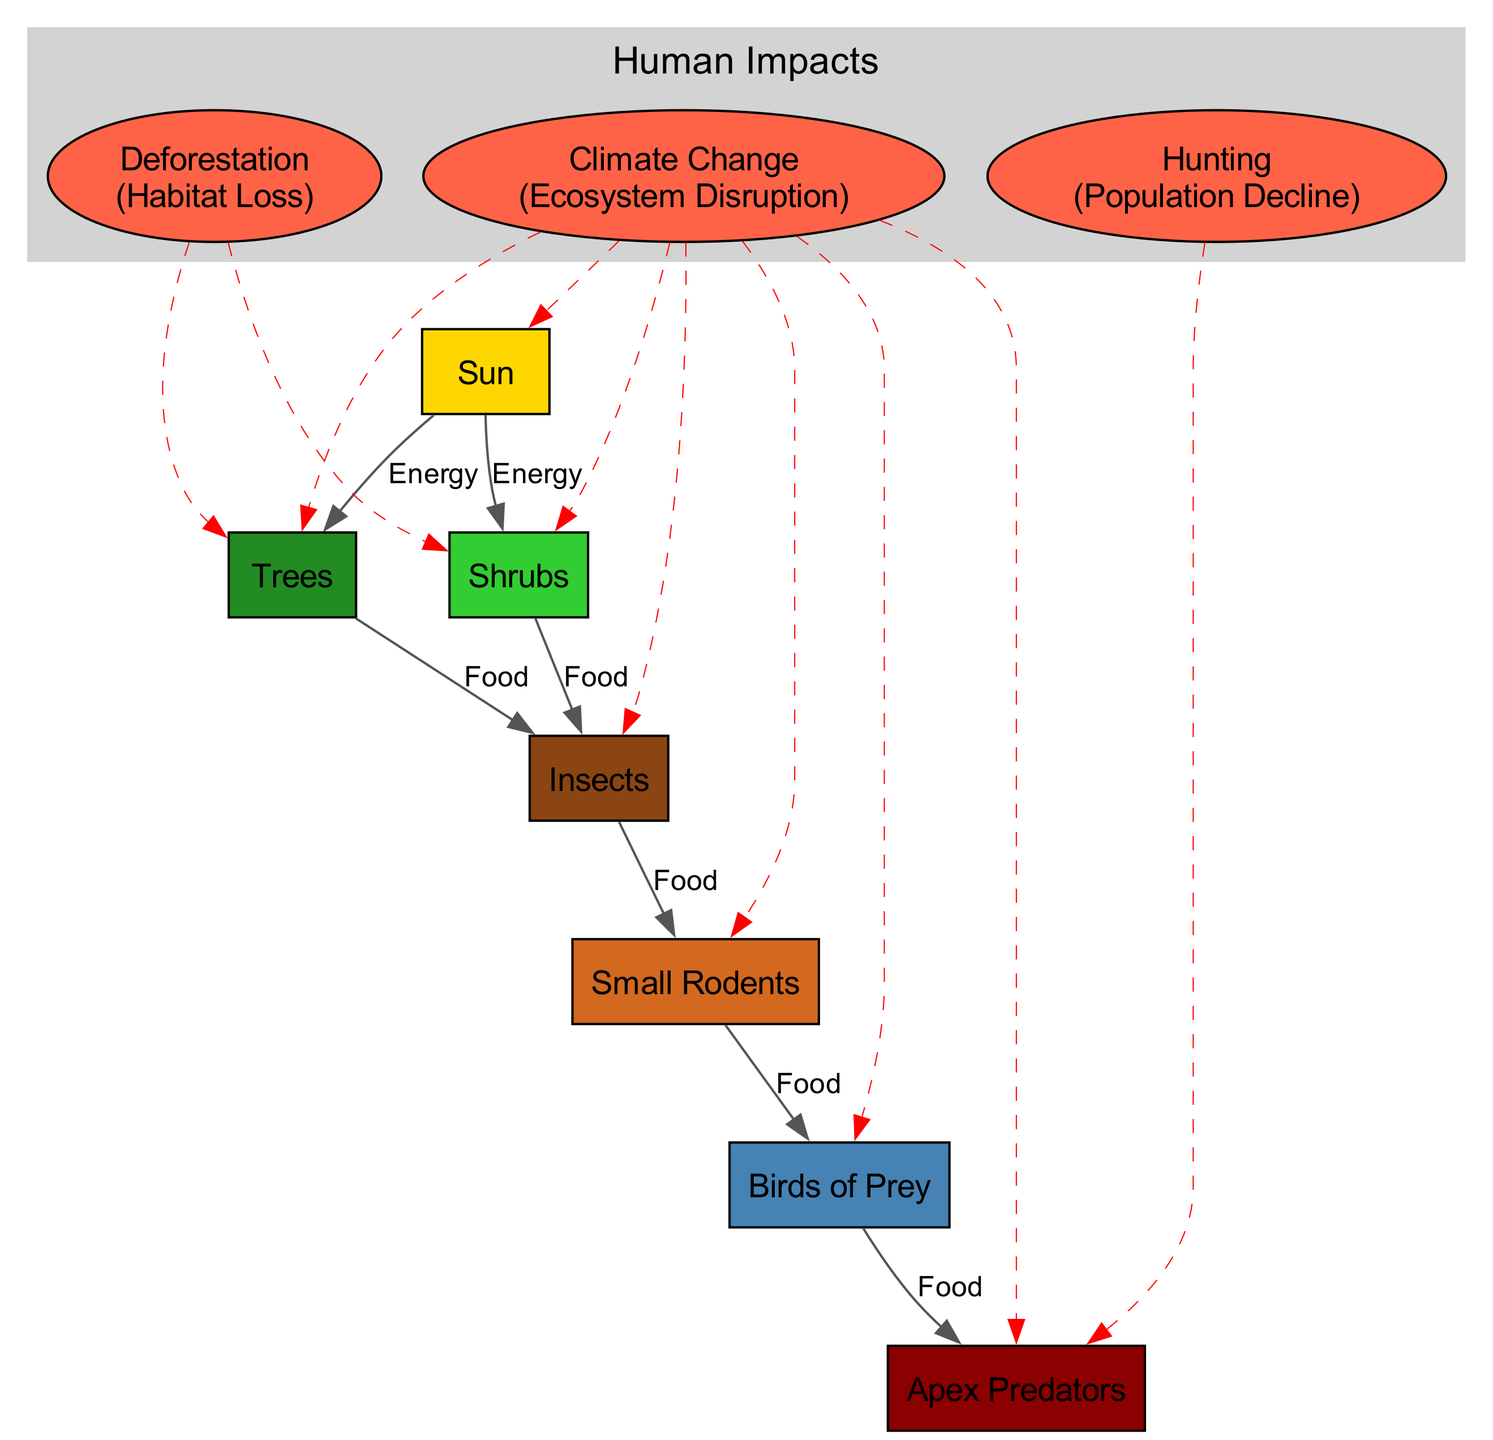What is the primary source of energy for the food chain? The diagram indicates that the Sun provides energy to both Trees and Shrubs, making it the primary energy source in the food chain.
Answer: Sun How many different types of producers are shown in the diagram? The diagram lists Trees and Shrubs as the producers, hence there are two different types.
Answer: 2 Which organism is the apex predator? According to the diagram, Birds of Prey feed into another organism that is labeled Apex Predators, indicating that is the apex predator in this food chain.
Answer: Apex Predators What human impact affects both Trees and Shrubs? The diagram states that Deforestation negatively impacts both Trees and Shrubs, leading to habitat loss in both.
Answer: Deforestation Which human impact is noted to affect all organisms? The diagram indicates that Climate Change affects all organisms, resulting in ecosystem disruption as a consequence.
Answer: Climate Change How many total relationships does the diagram illustrate? By counting all the relationships listed, there are a total of six direct feeding relationships shown in the diagram.
Answer: 6 What are the two consequences of human impacts shown in the diagram? The diagram notes two consequences: Habitat Loss due to Deforestation, and Population Decline due to Hunting, covering two different human impacts.
Answer: Habitat Loss, Population Decline Which organism is directly impacted by hunting? The diagram shows that hunting specifically affects Apex Predators, leading to a population decline for that group.
Answer: Apex Predators What type of relationship exists between Insects and Small Rodents? The diagram depicts a food relationship where Insects provide food to Small Rodents, indicating a direct feeding relationship between them.
Answer: Food 